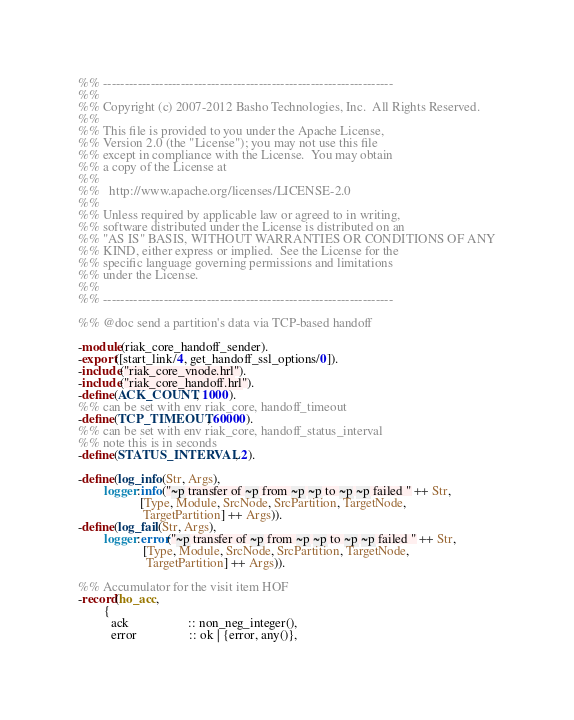<code> <loc_0><loc_0><loc_500><loc_500><_Erlang_>%% -------------------------------------------------------------------
%%
%% Copyright (c) 2007-2012 Basho Technologies, Inc.  All Rights Reserved.
%%
%% This file is provided to you under the Apache License,
%% Version 2.0 (the "License"); you may not use this file
%% except in compliance with the License.  You may obtain
%% a copy of the License at
%%
%%   http://www.apache.org/licenses/LICENSE-2.0
%%
%% Unless required by applicable law or agreed to in writing,
%% software distributed under the License is distributed on an
%% "AS IS" BASIS, WITHOUT WARRANTIES OR CONDITIONS OF ANY
%% KIND, either express or implied.  See the License for the
%% specific language governing permissions and limitations
%% under the License.
%%
%% -------------------------------------------------------------------

%% @doc send a partition's data via TCP-based handoff

-module(riak_core_handoff_sender).
-export([start_link/4, get_handoff_ssl_options/0]).
-include("riak_core_vnode.hrl").
-include("riak_core_handoff.hrl").
-define(ACK_COUNT, 1000).
%% can be set with env riak_core, handoff_timeout
-define(TCP_TIMEOUT, 60000).
%% can be set with env riak_core, handoff_status_interval
%% note this is in seconds
-define(STATUS_INTERVAL, 2).

-define(log_info(Str, Args),
        logger:info("~p transfer of ~p from ~p ~p to ~p ~p failed " ++ Str,
                   [Type, Module, SrcNode, SrcPartition, TargetNode,
                    TargetPartition] ++ Args)).
-define(log_fail(Str, Args),
        logger:error("~p transfer of ~p from ~p ~p to ~p ~p failed " ++ Str,
                    [Type, Module, SrcNode, SrcPartition, TargetNode,
                     TargetPartition] ++ Args)).

%% Accumulator for the visit item HOF
-record(ho_acc,
        {
          ack                  :: non_neg_integer(),
          error                :: ok | {error, any()},</code> 